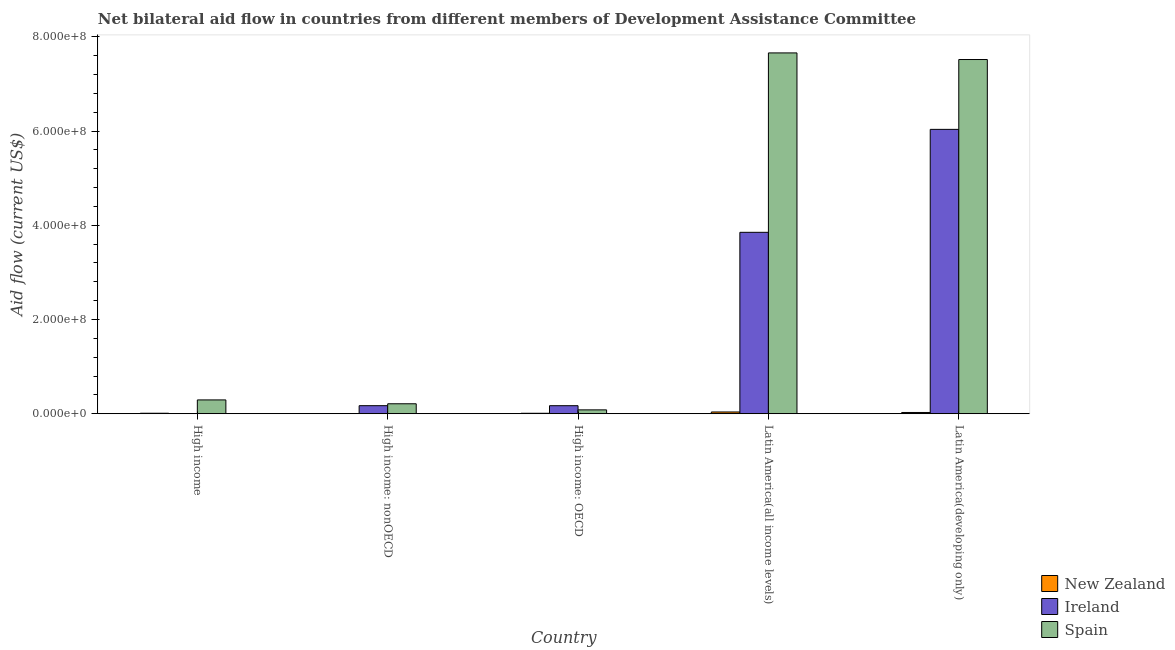How many groups of bars are there?
Your answer should be compact. 5. Are the number of bars per tick equal to the number of legend labels?
Your response must be concise. Yes. What is the label of the 4th group of bars from the left?
Provide a short and direct response. Latin America(all income levels). In how many cases, is the number of bars for a given country not equal to the number of legend labels?
Offer a very short reply. 0. What is the amount of aid provided by ireland in High income?
Your answer should be compact. 3.00e+04. Across all countries, what is the maximum amount of aid provided by new zealand?
Your response must be concise. 3.75e+06. Across all countries, what is the minimum amount of aid provided by ireland?
Provide a short and direct response. 3.00e+04. In which country was the amount of aid provided by spain maximum?
Provide a succinct answer. Latin America(all income levels). What is the total amount of aid provided by new zealand in the graph?
Your response must be concise. 8.56e+06. What is the difference between the amount of aid provided by ireland in High income: OECD and that in High income: nonOECD?
Ensure brevity in your answer.  -3.00e+04. What is the difference between the amount of aid provided by ireland in Latin America(all income levels) and the amount of aid provided by new zealand in High income: OECD?
Keep it short and to the point. 3.84e+08. What is the average amount of aid provided by ireland per country?
Give a very brief answer. 2.05e+08. What is the difference between the amount of aid provided by new zealand and amount of aid provided by ireland in High income: nonOECD?
Offer a very short reply. -1.70e+07. What is the ratio of the amount of aid provided by spain in High income: nonOECD to that in Latin America(developing only)?
Provide a succinct answer. 0.03. Is the difference between the amount of aid provided by ireland in High income: nonOECD and Latin America(all income levels) greater than the difference between the amount of aid provided by spain in High income: nonOECD and Latin America(all income levels)?
Provide a succinct answer. Yes. What is the difference between the highest and the second highest amount of aid provided by ireland?
Offer a terse response. 2.19e+08. What is the difference between the highest and the lowest amount of aid provided by ireland?
Offer a terse response. 6.04e+08. Is the sum of the amount of aid provided by ireland in High income and Latin America(developing only) greater than the maximum amount of aid provided by spain across all countries?
Ensure brevity in your answer.  No. What does the 1st bar from the left in High income represents?
Give a very brief answer. New Zealand. Are all the bars in the graph horizontal?
Your answer should be compact. No. Are the values on the major ticks of Y-axis written in scientific E-notation?
Offer a very short reply. Yes. Does the graph contain any zero values?
Provide a succinct answer. No. What is the title of the graph?
Offer a terse response. Net bilateral aid flow in countries from different members of Development Assistance Committee. Does "Tertiary education" appear as one of the legend labels in the graph?
Keep it short and to the point. No. What is the label or title of the X-axis?
Make the answer very short. Country. What is the label or title of the Y-axis?
Provide a succinct answer. Aid flow (current US$). What is the Aid flow (current US$) of New Zealand in High income?
Keep it short and to the point. 1.06e+06. What is the Aid flow (current US$) in Spain in High income?
Provide a succinct answer. 2.94e+07. What is the Aid flow (current US$) in New Zealand in High income: nonOECD?
Offer a very short reply. 8.00e+04. What is the Aid flow (current US$) of Ireland in High income: nonOECD?
Provide a short and direct response. 1.71e+07. What is the Aid flow (current US$) of Spain in High income: nonOECD?
Keep it short and to the point. 2.11e+07. What is the Aid flow (current US$) in New Zealand in High income: OECD?
Your answer should be compact. 9.80e+05. What is the Aid flow (current US$) in Ireland in High income: OECD?
Provide a succinct answer. 1.71e+07. What is the Aid flow (current US$) in Spain in High income: OECD?
Provide a short and direct response. 8.22e+06. What is the Aid flow (current US$) in New Zealand in Latin America(all income levels)?
Your answer should be compact. 3.75e+06. What is the Aid flow (current US$) of Ireland in Latin America(all income levels)?
Provide a succinct answer. 3.85e+08. What is the Aid flow (current US$) in Spain in Latin America(all income levels)?
Provide a short and direct response. 7.66e+08. What is the Aid flow (current US$) of New Zealand in Latin America(developing only)?
Provide a succinct answer. 2.69e+06. What is the Aid flow (current US$) in Ireland in Latin America(developing only)?
Ensure brevity in your answer.  6.04e+08. What is the Aid flow (current US$) in Spain in Latin America(developing only)?
Your answer should be compact. 7.52e+08. Across all countries, what is the maximum Aid flow (current US$) in New Zealand?
Offer a terse response. 3.75e+06. Across all countries, what is the maximum Aid flow (current US$) of Ireland?
Your answer should be very brief. 6.04e+08. Across all countries, what is the maximum Aid flow (current US$) of Spain?
Your answer should be very brief. 7.66e+08. Across all countries, what is the minimum Aid flow (current US$) of New Zealand?
Provide a short and direct response. 8.00e+04. Across all countries, what is the minimum Aid flow (current US$) in Ireland?
Your response must be concise. 3.00e+04. Across all countries, what is the minimum Aid flow (current US$) of Spain?
Keep it short and to the point. 8.22e+06. What is the total Aid flow (current US$) of New Zealand in the graph?
Your response must be concise. 8.56e+06. What is the total Aid flow (current US$) in Ireland in the graph?
Provide a short and direct response. 1.02e+09. What is the total Aid flow (current US$) in Spain in the graph?
Provide a short and direct response. 1.58e+09. What is the difference between the Aid flow (current US$) of New Zealand in High income and that in High income: nonOECD?
Keep it short and to the point. 9.80e+05. What is the difference between the Aid flow (current US$) of Ireland in High income and that in High income: nonOECD?
Your answer should be compact. -1.71e+07. What is the difference between the Aid flow (current US$) in Spain in High income and that in High income: nonOECD?
Your response must be concise. 8.22e+06. What is the difference between the Aid flow (current US$) of Ireland in High income and that in High income: OECD?
Offer a very short reply. -1.70e+07. What is the difference between the Aid flow (current US$) of Spain in High income and that in High income: OECD?
Ensure brevity in your answer.  2.11e+07. What is the difference between the Aid flow (current US$) of New Zealand in High income and that in Latin America(all income levels)?
Give a very brief answer. -2.69e+06. What is the difference between the Aid flow (current US$) of Ireland in High income and that in Latin America(all income levels)?
Make the answer very short. -3.85e+08. What is the difference between the Aid flow (current US$) of Spain in High income and that in Latin America(all income levels)?
Keep it short and to the point. -7.37e+08. What is the difference between the Aid flow (current US$) of New Zealand in High income and that in Latin America(developing only)?
Offer a terse response. -1.63e+06. What is the difference between the Aid flow (current US$) in Ireland in High income and that in Latin America(developing only)?
Make the answer very short. -6.04e+08. What is the difference between the Aid flow (current US$) in Spain in High income and that in Latin America(developing only)?
Offer a terse response. -7.23e+08. What is the difference between the Aid flow (current US$) of New Zealand in High income: nonOECD and that in High income: OECD?
Make the answer very short. -9.00e+05. What is the difference between the Aid flow (current US$) of Spain in High income: nonOECD and that in High income: OECD?
Make the answer very short. 1.29e+07. What is the difference between the Aid flow (current US$) of New Zealand in High income: nonOECD and that in Latin America(all income levels)?
Provide a short and direct response. -3.67e+06. What is the difference between the Aid flow (current US$) of Ireland in High income: nonOECD and that in Latin America(all income levels)?
Your answer should be compact. -3.68e+08. What is the difference between the Aid flow (current US$) in Spain in High income: nonOECD and that in Latin America(all income levels)?
Offer a terse response. -7.45e+08. What is the difference between the Aid flow (current US$) of New Zealand in High income: nonOECD and that in Latin America(developing only)?
Ensure brevity in your answer.  -2.61e+06. What is the difference between the Aid flow (current US$) of Ireland in High income: nonOECD and that in Latin America(developing only)?
Keep it short and to the point. -5.87e+08. What is the difference between the Aid flow (current US$) in Spain in High income: nonOECD and that in Latin America(developing only)?
Your answer should be very brief. -7.31e+08. What is the difference between the Aid flow (current US$) of New Zealand in High income: OECD and that in Latin America(all income levels)?
Provide a succinct answer. -2.77e+06. What is the difference between the Aid flow (current US$) of Ireland in High income: OECD and that in Latin America(all income levels)?
Provide a short and direct response. -3.68e+08. What is the difference between the Aid flow (current US$) of Spain in High income: OECD and that in Latin America(all income levels)?
Make the answer very short. -7.58e+08. What is the difference between the Aid flow (current US$) in New Zealand in High income: OECD and that in Latin America(developing only)?
Offer a very short reply. -1.71e+06. What is the difference between the Aid flow (current US$) of Ireland in High income: OECD and that in Latin America(developing only)?
Your answer should be very brief. -5.87e+08. What is the difference between the Aid flow (current US$) in Spain in High income: OECD and that in Latin America(developing only)?
Make the answer very short. -7.44e+08. What is the difference between the Aid flow (current US$) of New Zealand in Latin America(all income levels) and that in Latin America(developing only)?
Keep it short and to the point. 1.06e+06. What is the difference between the Aid flow (current US$) of Ireland in Latin America(all income levels) and that in Latin America(developing only)?
Your answer should be compact. -2.19e+08. What is the difference between the Aid flow (current US$) in Spain in Latin America(all income levels) and that in Latin America(developing only)?
Ensure brevity in your answer.  1.40e+07. What is the difference between the Aid flow (current US$) in New Zealand in High income and the Aid flow (current US$) in Ireland in High income: nonOECD?
Your answer should be very brief. -1.60e+07. What is the difference between the Aid flow (current US$) of New Zealand in High income and the Aid flow (current US$) of Spain in High income: nonOECD?
Your answer should be compact. -2.01e+07. What is the difference between the Aid flow (current US$) in Ireland in High income and the Aid flow (current US$) in Spain in High income: nonOECD?
Ensure brevity in your answer.  -2.11e+07. What is the difference between the Aid flow (current US$) of New Zealand in High income and the Aid flow (current US$) of Ireland in High income: OECD?
Keep it short and to the point. -1.60e+07. What is the difference between the Aid flow (current US$) of New Zealand in High income and the Aid flow (current US$) of Spain in High income: OECD?
Your answer should be compact. -7.16e+06. What is the difference between the Aid flow (current US$) in Ireland in High income and the Aid flow (current US$) in Spain in High income: OECD?
Make the answer very short. -8.19e+06. What is the difference between the Aid flow (current US$) of New Zealand in High income and the Aid flow (current US$) of Ireland in Latin America(all income levels)?
Offer a terse response. -3.84e+08. What is the difference between the Aid flow (current US$) in New Zealand in High income and the Aid flow (current US$) in Spain in Latin America(all income levels)?
Offer a terse response. -7.65e+08. What is the difference between the Aid flow (current US$) in Ireland in High income and the Aid flow (current US$) in Spain in Latin America(all income levels)?
Your answer should be compact. -7.66e+08. What is the difference between the Aid flow (current US$) of New Zealand in High income and the Aid flow (current US$) of Ireland in Latin America(developing only)?
Provide a short and direct response. -6.03e+08. What is the difference between the Aid flow (current US$) in New Zealand in High income and the Aid flow (current US$) in Spain in Latin America(developing only)?
Ensure brevity in your answer.  -7.51e+08. What is the difference between the Aid flow (current US$) of Ireland in High income and the Aid flow (current US$) of Spain in Latin America(developing only)?
Your answer should be very brief. -7.52e+08. What is the difference between the Aid flow (current US$) in New Zealand in High income: nonOECD and the Aid flow (current US$) in Ireland in High income: OECD?
Your response must be concise. -1.70e+07. What is the difference between the Aid flow (current US$) of New Zealand in High income: nonOECD and the Aid flow (current US$) of Spain in High income: OECD?
Give a very brief answer. -8.14e+06. What is the difference between the Aid flow (current US$) of Ireland in High income: nonOECD and the Aid flow (current US$) of Spain in High income: OECD?
Offer a very short reply. 8.88e+06. What is the difference between the Aid flow (current US$) in New Zealand in High income: nonOECD and the Aid flow (current US$) in Ireland in Latin America(all income levels)?
Offer a very short reply. -3.85e+08. What is the difference between the Aid flow (current US$) in New Zealand in High income: nonOECD and the Aid flow (current US$) in Spain in Latin America(all income levels)?
Give a very brief answer. -7.66e+08. What is the difference between the Aid flow (current US$) in Ireland in High income: nonOECD and the Aid flow (current US$) in Spain in Latin America(all income levels)?
Offer a terse response. -7.49e+08. What is the difference between the Aid flow (current US$) of New Zealand in High income: nonOECD and the Aid flow (current US$) of Ireland in Latin America(developing only)?
Keep it short and to the point. -6.04e+08. What is the difference between the Aid flow (current US$) of New Zealand in High income: nonOECD and the Aid flow (current US$) of Spain in Latin America(developing only)?
Offer a very short reply. -7.52e+08. What is the difference between the Aid flow (current US$) in Ireland in High income: nonOECD and the Aid flow (current US$) in Spain in Latin America(developing only)?
Make the answer very short. -7.35e+08. What is the difference between the Aid flow (current US$) of New Zealand in High income: OECD and the Aid flow (current US$) of Ireland in Latin America(all income levels)?
Offer a very short reply. -3.84e+08. What is the difference between the Aid flow (current US$) of New Zealand in High income: OECD and the Aid flow (current US$) of Spain in Latin America(all income levels)?
Your response must be concise. -7.65e+08. What is the difference between the Aid flow (current US$) in Ireland in High income: OECD and the Aid flow (current US$) in Spain in Latin America(all income levels)?
Make the answer very short. -7.49e+08. What is the difference between the Aid flow (current US$) in New Zealand in High income: OECD and the Aid flow (current US$) in Ireland in Latin America(developing only)?
Keep it short and to the point. -6.03e+08. What is the difference between the Aid flow (current US$) of New Zealand in High income: OECD and the Aid flow (current US$) of Spain in Latin America(developing only)?
Keep it short and to the point. -7.51e+08. What is the difference between the Aid flow (current US$) of Ireland in High income: OECD and the Aid flow (current US$) of Spain in Latin America(developing only)?
Keep it short and to the point. -7.35e+08. What is the difference between the Aid flow (current US$) of New Zealand in Latin America(all income levels) and the Aid flow (current US$) of Ireland in Latin America(developing only)?
Give a very brief answer. -6.00e+08. What is the difference between the Aid flow (current US$) of New Zealand in Latin America(all income levels) and the Aid flow (current US$) of Spain in Latin America(developing only)?
Your answer should be compact. -7.48e+08. What is the difference between the Aid flow (current US$) in Ireland in Latin America(all income levels) and the Aid flow (current US$) in Spain in Latin America(developing only)?
Make the answer very short. -3.67e+08. What is the average Aid flow (current US$) in New Zealand per country?
Keep it short and to the point. 1.71e+06. What is the average Aid flow (current US$) of Ireland per country?
Your response must be concise. 2.05e+08. What is the average Aid flow (current US$) of Spain per country?
Your response must be concise. 3.15e+08. What is the difference between the Aid flow (current US$) of New Zealand and Aid flow (current US$) of Ireland in High income?
Offer a very short reply. 1.03e+06. What is the difference between the Aid flow (current US$) of New Zealand and Aid flow (current US$) of Spain in High income?
Ensure brevity in your answer.  -2.83e+07. What is the difference between the Aid flow (current US$) in Ireland and Aid flow (current US$) in Spain in High income?
Give a very brief answer. -2.93e+07. What is the difference between the Aid flow (current US$) of New Zealand and Aid flow (current US$) of Ireland in High income: nonOECD?
Keep it short and to the point. -1.70e+07. What is the difference between the Aid flow (current US$) of New Zealand and Aid flow (current US$) of Spain in High income: nonOECD?
Ensure brevity in your answer.  -2.11e+07. What is the difference between the Aid flow (current US$) in Ireland and Aid flow (current US$) in Spain in High income: nonOECD?
Provide a short and direct response. -4.04e+06. What is the difference between the Aid flow (current US$) of New Zealand and Aid flow (current US$) of Ireland in High income: OECD?
Keep it short and to the point. -1.61e+07. What is the difference between the Aid flow (current US$) of New Zealand and Aid flow (current US$) of Spain in High income: OECD?
Your answer should be very brief. -7.24e+06. What is the difference between the Aid flow (current US$) of Ireland and Aid flow (current US$) of Spain in High income: OECD?
Keep it short and to the point. 8.85e+06. What is the difference between the Aid flow (current US$) of New Zealand and Aid flow (current US$) of Ireland in Latin America(all income levels)?
Provide a short and direct response. -3.81e+08. What is the difference between the Aid flow (current US$) of New Zealand and Aid flow (current US$) of Spain in Latin America(all income levels)?
Offer a terse response. -7.62e+08. What is the difference between the Aid flow (current US$) of Ireland and Aid flow (current US$) of Spain in Latin America(all income levels)?
Make the answer very short. -3.81e+08. What is the difference between the Aid flow (current US$) of New Zealand and Aid flow (current US$) of Ireland in Latin America(developing only)?
Make the answer very short. -6.01e+08. What is the difference between the Aid flow (current US$) of New Zealand and Aid flow (current US$) of Spain in Latin America(developing only)?
Keep it short and to the point. -7.49e+08. What is the difference between the Aid flow (current US$) in Ireland and Aid flow (current US$) in Spain in Latin America(developing only)?
Keep it short and to the point. -1.48e+08. What is the ratio of the Aid flow (current US$) of New Zealand in High income to that in High income: nonOECD?
Offer a terse response. 13.25. What is the ratio of the Aid flow (current US$) in Ireland in High income to that in High income: nonOECD?
Your answer should be very brief. 0. What is the ratio of the Aid flow (current US$) of Spain in High income to that in High income: nonOECD?
Provide a succinct answer. 1.39. What is the ratio of the Aid flow (current US$) in New Zealand in High income to that in High income: OECD?
Provide a succinct answer. 1.08. What is the ratio of the Aid flow (current US$) of Ireland in High income to that in High income: OECD?
Your response must be concise. 0. What is the ratio of the Aid flow (current US$) of Spain in High income to that in High income: OECD?
Keep it short and to the point. 3.57. What is the ratio of the Aid flow (current US$) of New Zealand in High income to that in Latin America(all income levels)?
Keep it short and to the point. 0.28. What is the ratio of the Aid flow (current US$) of Spain in High income to that in Latin America(all income levels)?
Offer a terse response. 0.04. What is the ratio of the Aid flow (current US$) of New Zealand in High income to that in Latin America(developing only)?
Give a very brief answer. 0.39. What is the ratio of the Aid flow (current US$) of Spain in High income to that in Latin America(developing only)?
Provide a short and direct response. 0.04. What is the ratio of the Aid flow (current US$) in New Zealand in High income: nonOECD to that in High income: OECD?
Provide a short and direct response. 0.08. What is the ratio of the Aid flow (current US$) in Spain in High income: nonOECD to that in High income: OECD?
Your answer should be compact. 2.57. What is the ratio of the Aid flow (current US$) in New Zealand in High income: nonOECD to that in Latin America(all income levels)?
Your answer should be very brief. 0.02. What is the ratio of the Aid flow (current US$) of Ireland in High income: nonOECD to that in Latin America(all income levels)?
Offer a terse response. 0.04. What is the ratio of the Aid flow (current US$) of Spain in High income: nonOECD to that in Latin America(all income levels)?
Ensure brevity in your answer.  0.03. What is the ratio of the Aid flow (current US$) of New Zealand in High income: nonOECD to that in Latin America(developing only)?
Ensure brevity in your answer.  0.03. What is the ratio of the Aid flow (current US$) in Ireland in High income: nonOECD to that in Latin America(developing only)?
Offer a terse response. 0.03. What is the ratio of the Aid flow (current US$) of Spain in High income: nonOECD to that in Latin America(developing only)?
Provide a short and direct response. 0.03. What is the ratio of the Aid flow (current US$) in New Zealand in High income: OECD to that in Latin America(all income levels)?
Provide a short and direct response. 0.26. What is the ratio of the Aid flow (current US$) of Ireland in High income: OECD to that in Latin America(all income levels)?
Make the answer very short. 0.04. What is the ratio of the Aid flow (current US$) in Spain in High income: OECD to that in Latin America(all income levels)?
Your answer should be very brief. 0.01. What is the ratio of the Aid flow (current US$) of New Zealand in High income: OECD to that in Latin America(developing only)?
Provide a short and direct response. 0.36. What is the ratio of the Aid flow (current US$) of Ireland in High income: OECD to that in Latin America(developing only)?
Make the answer very short. 0.03. What is the ratio of the Aid flow (current US$) of Spain in High income: OECD to that in Latin America(developing only)?
Your answer should be very brief. 0.01. What is the ratio of the Aid flow (current US$) in New Zealand in Latin America(all income levels) to that in Latin America(developing only)?
Your answer should be very brief. 1.39. What is the ratio of the Aid flow (current US$) of Ireland in Latin America(all income levels) to that in Latin America(developing only)?
Give a very brief answer. 0.64. What is the ratio of the Aid flow (current US$) of Spain in Latin America(all income levels) to that in Latin America(developing only)?
Provide a short and direct response. 1.02. What is the difference between the highest and the second highest Aid flow (current US$) of New Zealand?
Offer a very short reply. 1.06e+06. What is the difference between the highest and the second highest Aid flow (current US$) of Ireland?
Keep it short and to the point. 2.19e+08. What is the difference between the highest and the second highest Aid flow (current US$) in Spain?
Make the answer very short. 1.40e+07. What is the difference between the highest and the lowest Aid flow (current US$) of New Zealand?
Ensure brevity in your answer.  3.67e+06. What is the difference between the highest and the lowest Aid flow (current US$) of Ireland?
Make the answer very short. 6.04e+08. What is the difference between the highest and the lowest Aid flow (current US$) in Spain?
Give a very brief answer. 7.58e+08. 